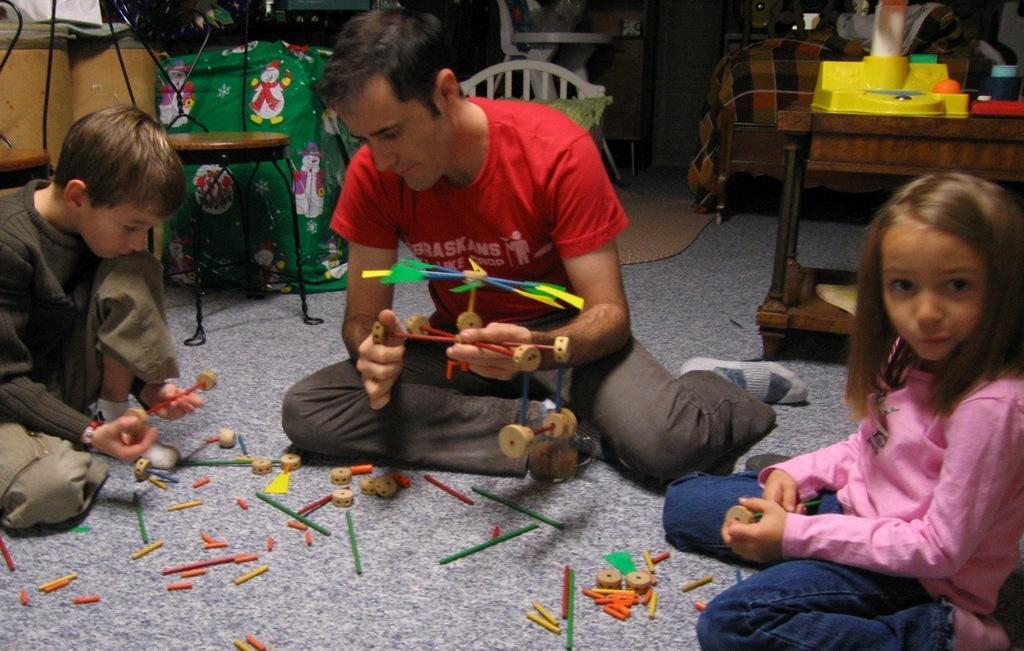Can you describe this image briefly? There is a man and two children are sitting on floor. They are playing with toys. In the back there are chairs, table. On the table there are some items. Also there are many other things in the background. 